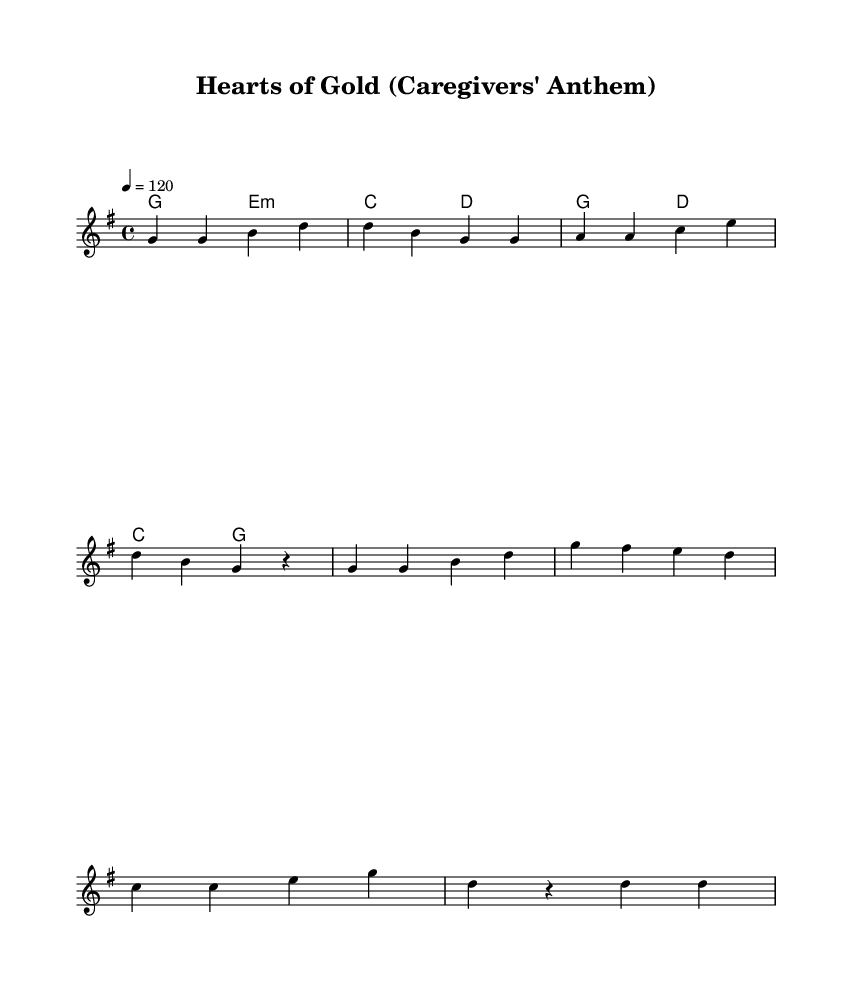What is the key signature of this music? The key signature indicated in the sheet music is G major, which has one sharp (F#). This can typically be identified at the beginning of the staff where sharps or flats are shown.
Answer: G major What is the time signature of this piece? The time signature located at the beginning of the music indicates 4/4 time, which means there are four beats in each measure and the quarter note receives one beat.
Answer: 4/4 What is the tempo marking for this piece? The tempo marking shows a quarter note equals 120. This indicates that each quarter note is to be played at a speed of 120 beats per minute.
Answer: 120 How many measures are in the verse section? The verse section consists of four measures, as indicated by the grouping of music notation before the chorus begins. Each line of the melody typically represents a measure.
Answer: Four How many times is the chorus repeated in the song structure? The chorus is displayed as a distinct section after the verse, and based on the structure, it closely resembles the verse but isn't explicitly labeled as repeated in this notation. Therefore, it can be inferred to be sung once after the verse.
Answer: One What theme or message is conveyed in the lyrics of this song? The lyrics emphasize the noble qualities and hard work of caregivers, depicting them as heroes who provide care and support to those in need, resonating with the anthem's intent to celebrate their efforts.
Answer: Caregivers as heroes 